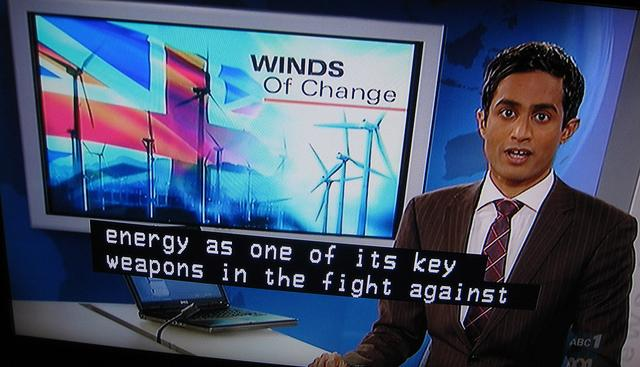Which national flag is in the segment screen of this broadcast? Please explain your reasoning. uk. The other options have different flags. 